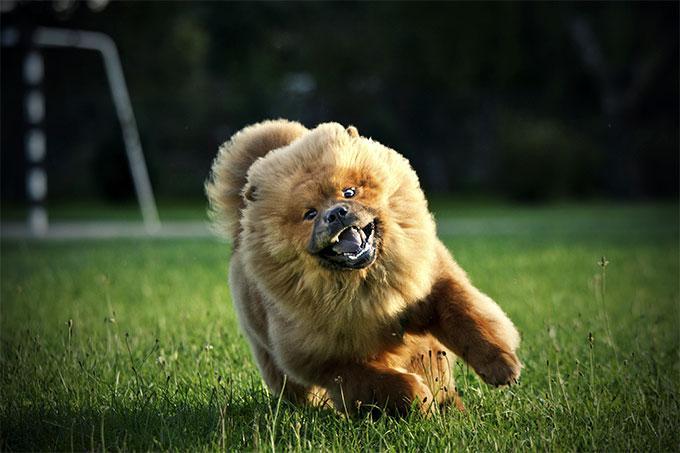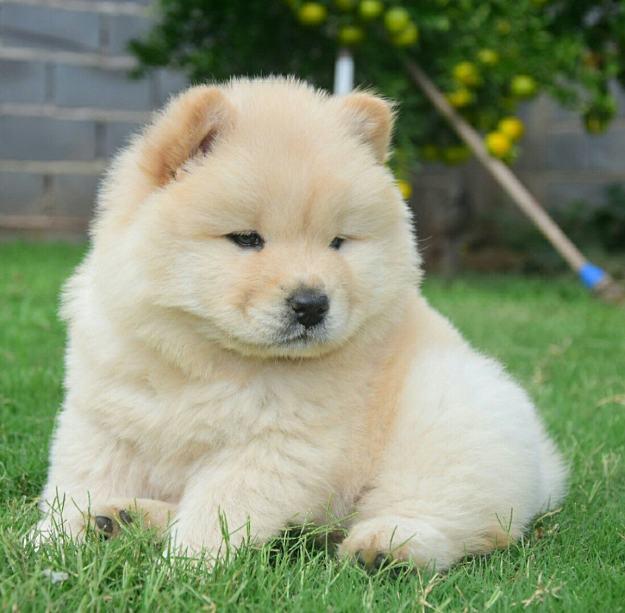The first image is the image on the left, the second image is the image on the right. Given the left and right images, does the statement "There are two dogs, and neither of them has anything in their mouth." hold true? Answer yes or no. Yes. The first image is the image on the left, the second image is the image on the right. Examine the images to the left and right. Is the description "An image shows one cream-colored chow in a non-standing pose on the grass." accurate? Answer yes or no. Yes. 